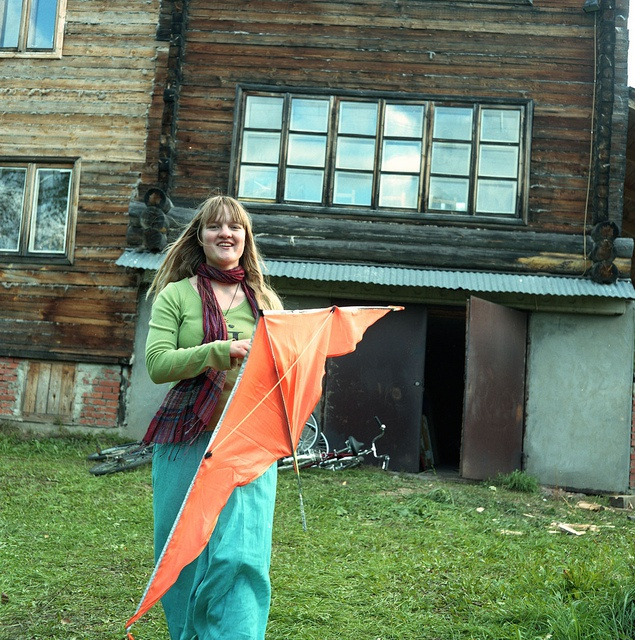Describe the objects in this image and their specific colors. I can see people in lightblue, teal, black, and turquoise tones, kite in lightblue, salmon, and tan tones, bicycle in lightblue, black, teal, and white tones, bicycle in lightblue, teal, and black tones, and bicycle in lightblue, teal, and black tones in this image. 